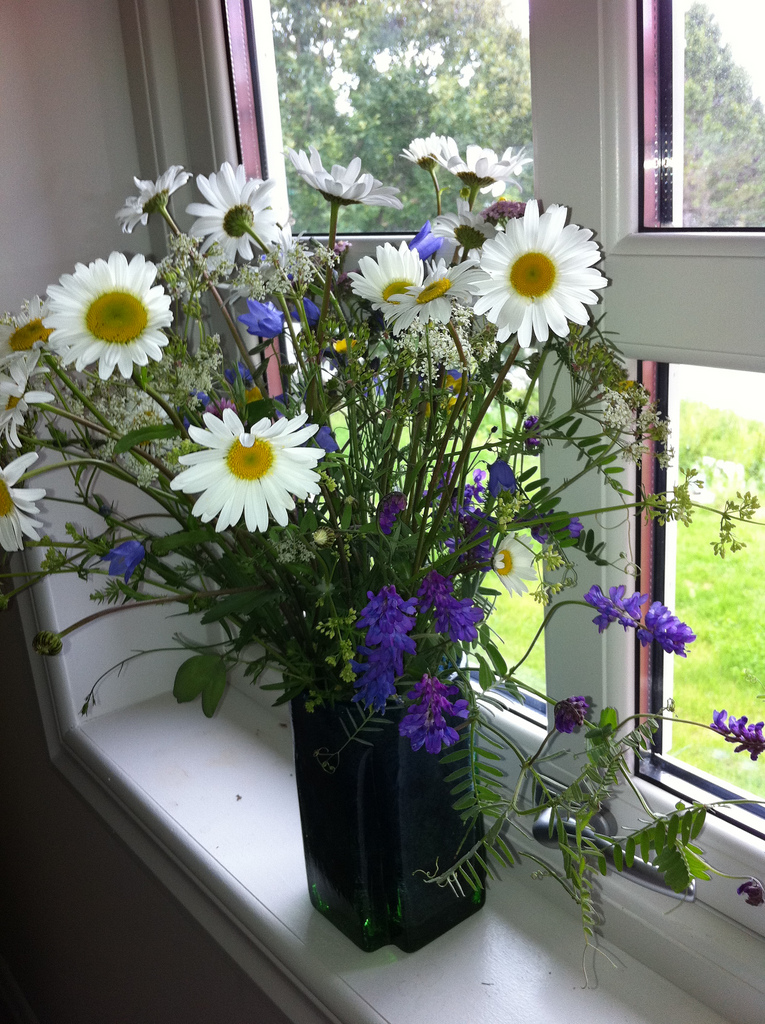What kind of flowers are in the vase? The vase contains a beautiful arrangement of wildflowers, including daisies and purple bell-shaped flowers. What colors do you see in the bouquet? The bouquet showcases a mix of white, yellow, purple, and hints of green from the stems and leaves. Describe the vase in detail. The vase is tall and made of dark green glass, which adds a solid yet elegant touch to the arrangement. The dark hue accentuates the vibrant colors of the flowers, creating a striking contrast. Imagine if these flowers had personalities. How would they interact with each other in a garden? In a whimsical garden world, the daisies might act as cheerful conversationalists, always eager to greet the sun and share stories. The purple bell-shaped flowers could be the mysterious and poetic ones, sharing secrets in the soft breeze. The greenery would play the role of supportive friends, providing a lush backdrop for all the lively interactions. Together, they'd create a vibrant community, enjoying the simplicity of nature and encouraging each other to bloom their brightest. Imagine you're planning a picnic next to this window. Describe the setting. Planning a picnic next to this window would be delightful. Picture a cozy blanket spread on the floor, with an assortment of fruits, cheeses, and sandwiches laid out. The window's soft light filters through, casting a gentle glow over the setting. The wildflower bouquet adds an aromatic and visual enhancement, making the space feel both relaxed and elegant. Outside, a verdant lawn adds to the serene atmosphere, making it a perfect spot for an afternoon of leisure and light-hearted conversation. 